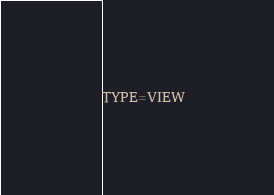<code> <loc_0><loc_0><loc_500><loc_500><_VisualBasic_>TYPE=VIEW</code> 